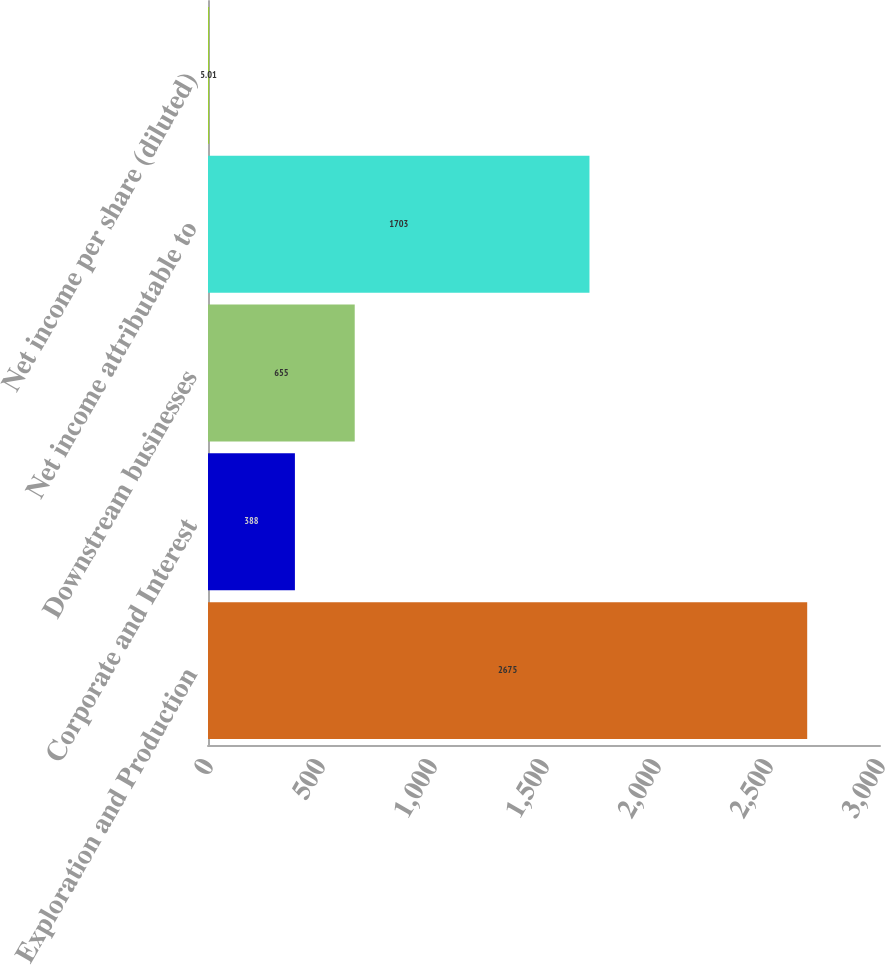Convert chart. <chart><loc_0><loc_0><loc_500><loc_500><bar_chart><fcel>Exploration and Production<fcel>Corporate and Interest<fcel>Downstream businesses<fcel>Net income attributable to<fcel>Net income per share (diluted)<nl><fcel>2675<fcel>388<fcel>655<fcel>1703<fcel>5.01<nl></chart> 